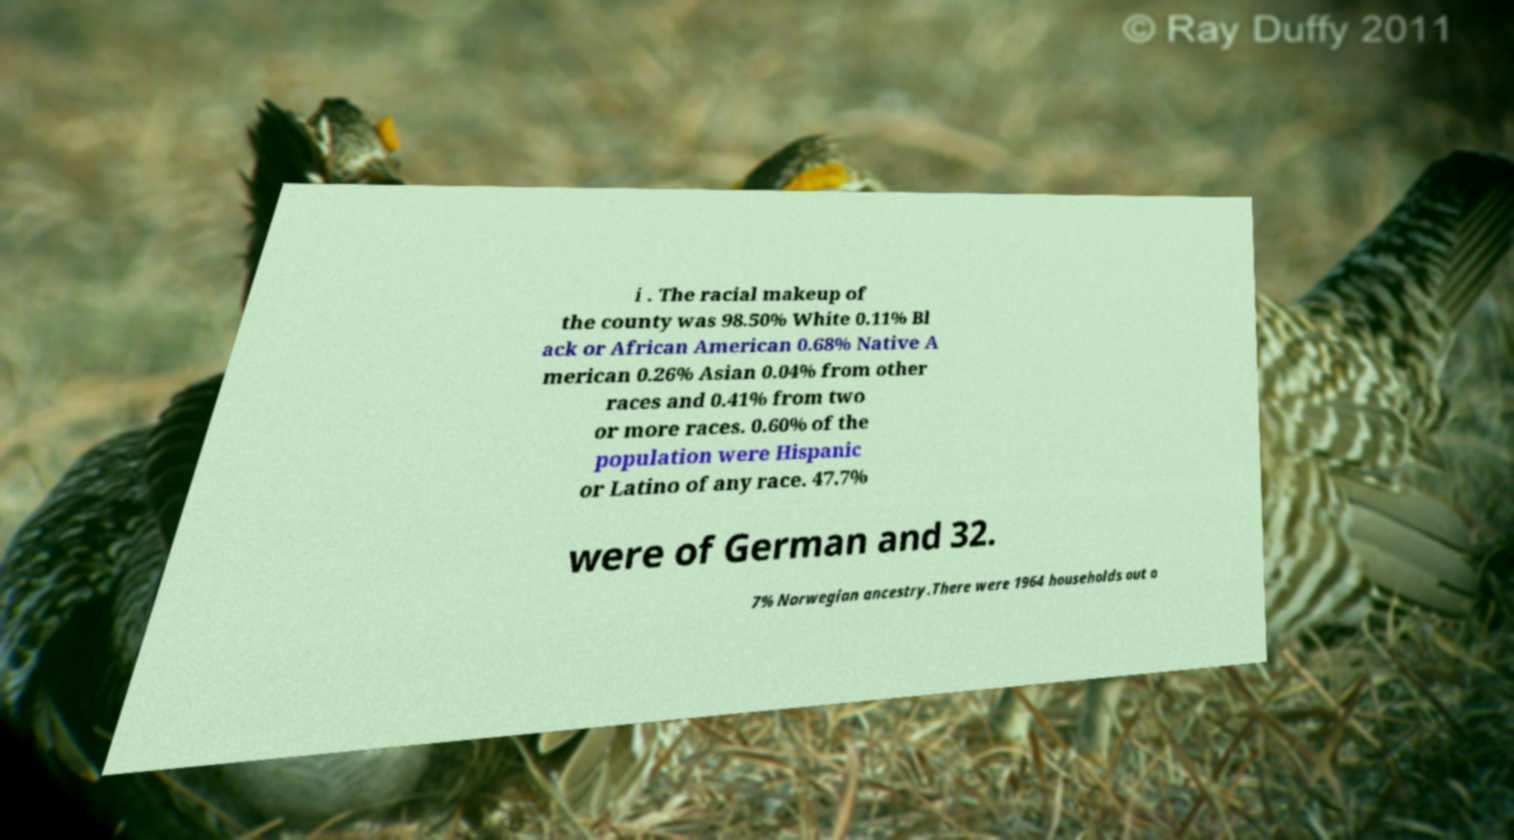I need the written content from this picture converted into text. Can you do that? i . The racial makeup of the county was 98.50% White 0.11% Bl ack or African American 0.68% Native A merican 0.26% Asian 0.04% from other races and 0.41% from two or more races. 0.60% of the population were Hispanic or Latino of any race. 47.7% were of German and 32. 7% Norwegian ancestry.There were 1964 households out o 